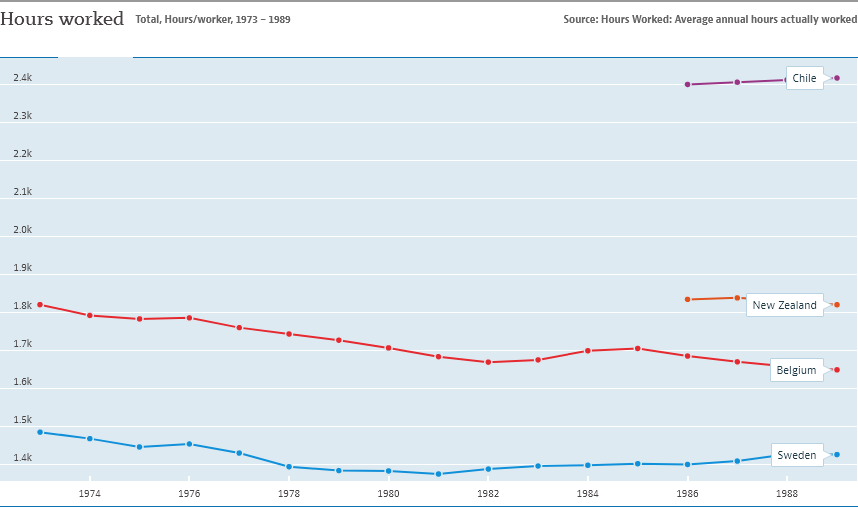Draw attention to some important aspects in this diagram. The country with its hours worked value ranging between 1,800 and 1,900 is either Belgium or New Zealand. The given text describes a graph that includes four countries: Chile, New Zealand, Belgium, and Sweden. 